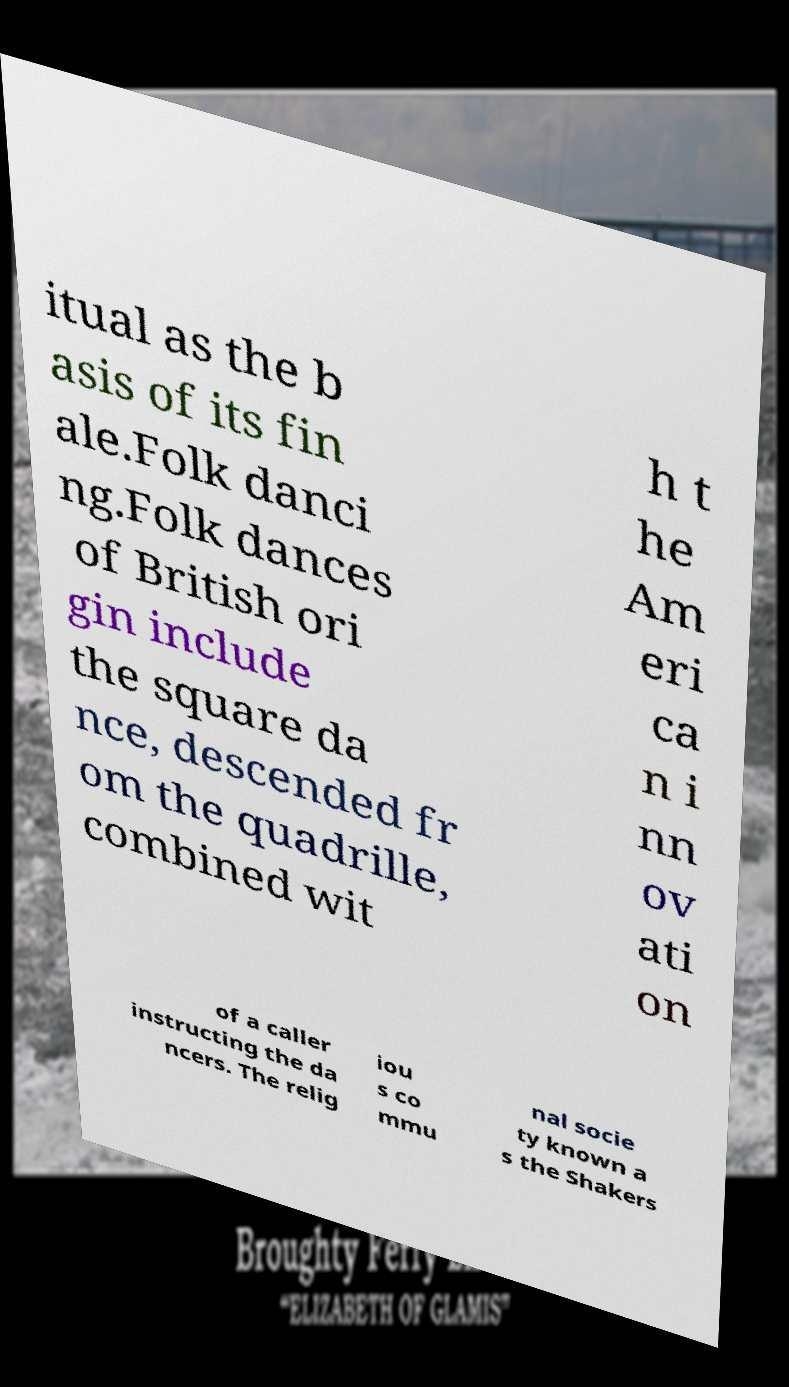Could you assist in decoding the text presented in this image and type it out clearly? itual as the b asis of its fin ale.Folk danci ng.Folk dances of British ori gin include the square da nce, descended fr om the quadrille, combined wit h t he Am eri ca n i nn ov ati on of a caller instructing the da ncers. The relig iou s co mmu nal socie ty known a s the Shakers 